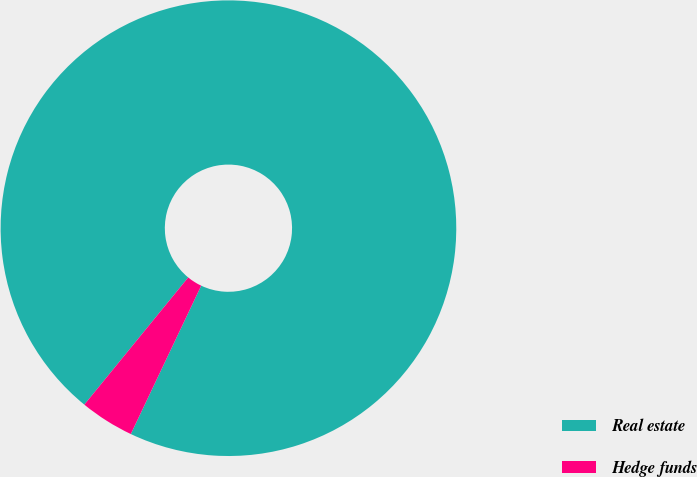<chart> <loc_0><loc_0><loc_500><loc_500><pie_chart><fcel>Real estate<fcel>Hedge funds<nl><fcel>96.15%<fcel>3.85%<nl></chart> 